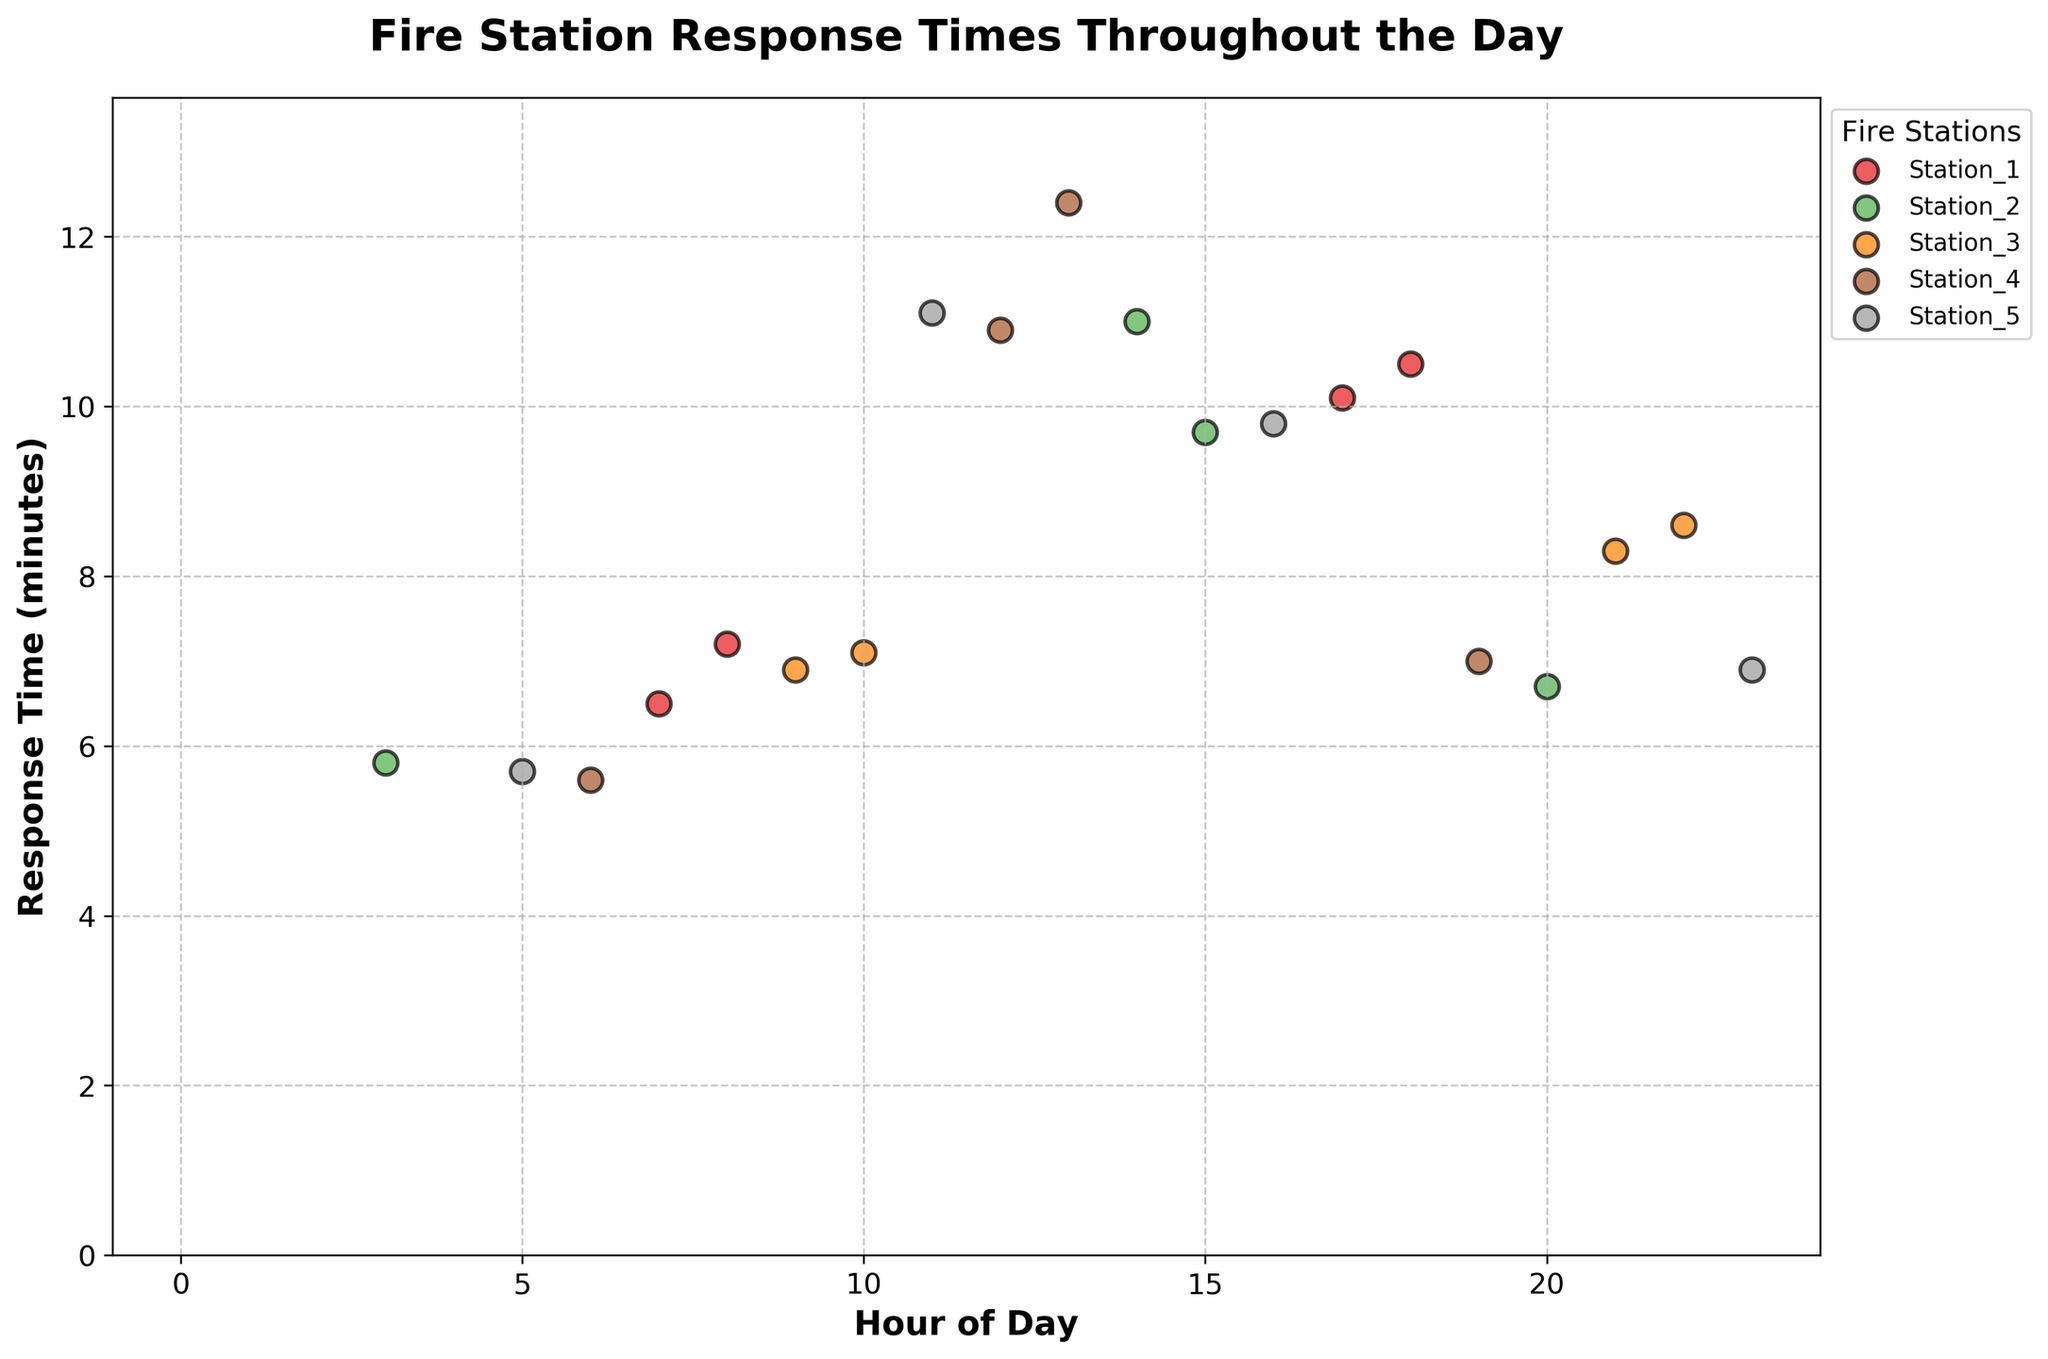What is the title of the figure? The title of the figure is usually at the top, prominently displayed. In this figure, it reads "Fire Station Response Times Throughout the Day".
Answer: Fire Station Response Times Throughout the Day What does the x-axis represent? The x-axis represents the hour of the day. This is shown by the label 'Hour of Day'.
Answer: Hour of Day Which fire station has the highest response time during peak hours? Peak hours are typically considered to be late afternoon and early evening. Evaluating the points for each station, Station_4 has the highest response time during peak hours with a time of 12.4 minutes at 13:00 hours.
Answer: Station_4 During which hours does Station_3 have response times recorded? By looking at the scatter points for Station_3, we can see that it has recorded response times at 9, 10, 21, and 22 hours.
Answer: 9, 10, 21, 22 Which station has the lowest average response time? To find the lowest average, calculate the average response time for each station and compare. Station_5's response times are (5.7 + 11.1 + 9.8 + 6.9)/4 = 8.375. Comparing this with other averages: Station_1: (6.5 + 7.2 + 10.1 + 10.5)/4 = 8.575, Station_2: (5.8 + 11 + 9.7 + 6.7)/4 = 8.3, Station_3: (6.9 + 7.1 + 8.3 + 8.6)/4 = 7.725, Station_4: (5.6 + 10.9 + 12.4 + 7)/4 = 9. In this evaluation, Station_3 has the lowest average response time.
Answer: Station_3 Which station has the maximum response time during off-peak hours? Off-peak hours are typically early morning and late evening. Looking at the scatter points, Station_4 has the maximum response time during off-peak hours with 10.9 minutes at 12:00 hours.
Answer: Station_4 Which station has the most consistent response times, and how do you define consistent in this context? Consistency can refer to less variability in response times. Calculating the standard deviation or visually inspecting the spread of points for each station, Station_3 appears most consistent as its response times (6.9, 7.1, 8.3, 8.6) are relatively close to each other.
Answer: Station_3 At what hour does Station_2 have its peak response time? For Station_2, look at the scatter points to identify the maximum value. The highest response time is 11.0 minutes at 14:00 hours.
Answer: 14:00 Which fire stations have response times exceeding 10 minutes? Identify scatter points above the 10-minute mark for each station. Station_1 (17 and 18 hours), Station_2 (14 hours), and Station_5 (11 hours) have response times exceeding 10 minutes.
Answer: Station_1, Station_2, Station_5 